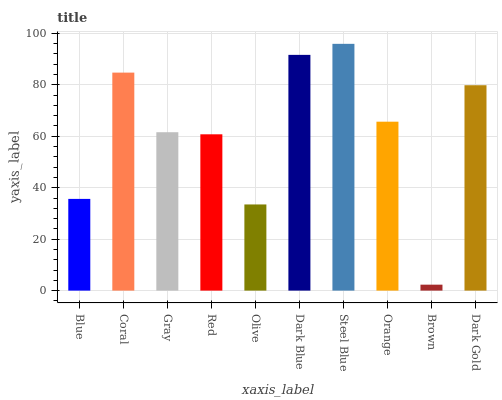Is Coral the minimum?
Answer yes or no. No. Is Coral the maximum?
Answer yes or no. No. Is Coral greater than Blue?
Answer yes or no. Yes. Is Blue less than Coral?
Answer yes or no. Yes. Is Blue greater than Coral?
Answer yes or no. No. Is Coral less than Blue?
Answer yes or no. No. Is Orange the high median?
Answer yes or no. Yes. Is Gray the low median?
Answer yes or no. Yes. Is Dark Gold the high median?
Answer yes or no. No. Is Red the low median?
Answer yes or no. No. 